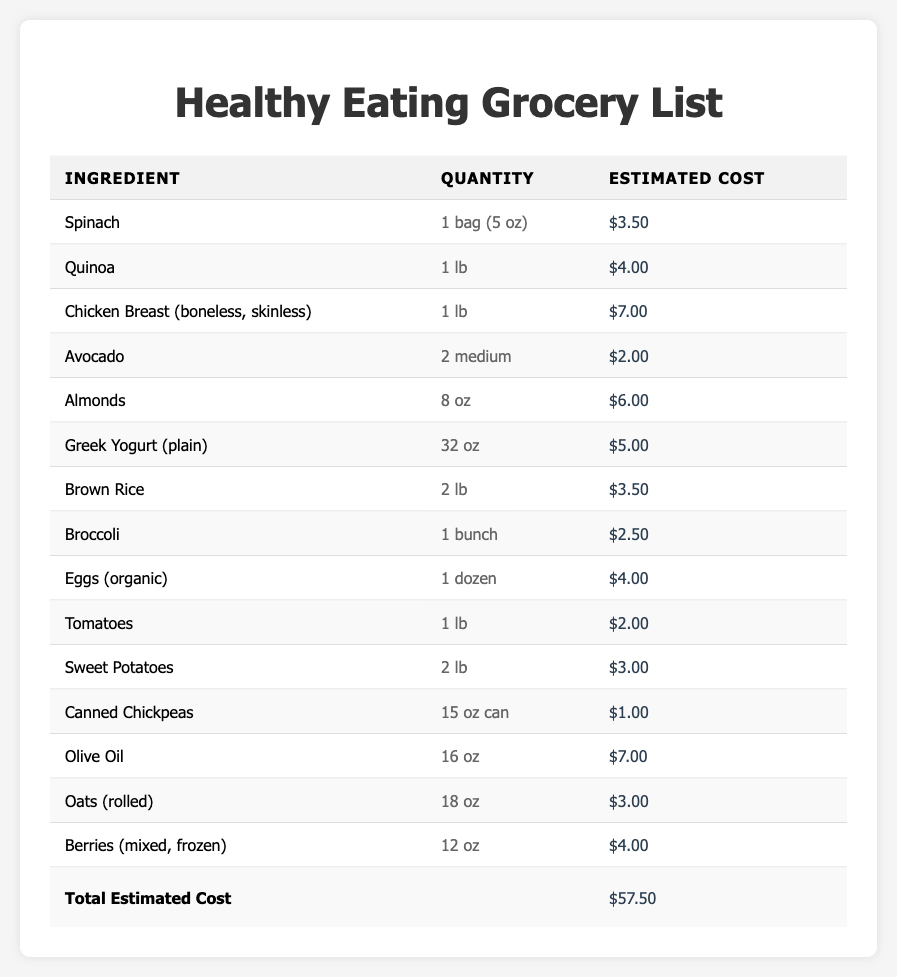What is the estimated cost of quinoa? The table lists "Quinoa" with an "Estimated Cost" of $4.00.
Answer: $4.00 How many ounces of almonds are included in the grocery list? The table shows that "Almonds" is listed with a quantity of "8 oz."
Answer: 8 oz What is the total estimated cost of the ingredients in the grocery list? The table indicates that the total estimated cost at the bottom is $57.50.
Answer: $57.50 Which ingredient costs the most? Looking through the estimated costs, "Chicken Breast (boneless, skinless)" at $7.00 is the highest listed.
Answer: Chicken Breast (boneless, skinless) Are there any ingredients priced under $2.00? "Canned Chickpeas" at $1.00 and "Tomatoes" at $2.00 are both below $2.00, confirming the presence of an ingredient priced under $2.00.
Answer: Yes What is the average estimated cost of the ingredients? The total cost is $57.50, and there are 15 ingredients. Dividing the total by 15 gives an average of $3.83 ($57.50 / 15).
Answer: $3.83 Does the grocery list contain any organic items? "Eggs (organic)" is explicitly listed as organic in the table.
Answer: Yes If I buy one of each ingredient, how much will I spend on just vegetables? The vegetables listed are Spinach ($3.50), Broccoli ($2.50), Tomatoes ($2.00), and Sweet Potatoes ($3.00). Adding these gives $3.50 + $2.50 + $2.00 + $3.00 = $11.00.
Answer: $11.00 What is the total cost of nuts and seeds? The list includes only "Almonds" at $6.00. Since it is the only item in this category, the total is $6.00.
Answer: $6.00 Which ingredient has the highest price per ounce? The ingredient with the highest cost is "Olive Oil," at $7.00 for 16 oz. To find price per ounce: $7.00 / 16 oz = $0.44/oz, making it the highest priced per ounce.
Answer: Olive Oil 